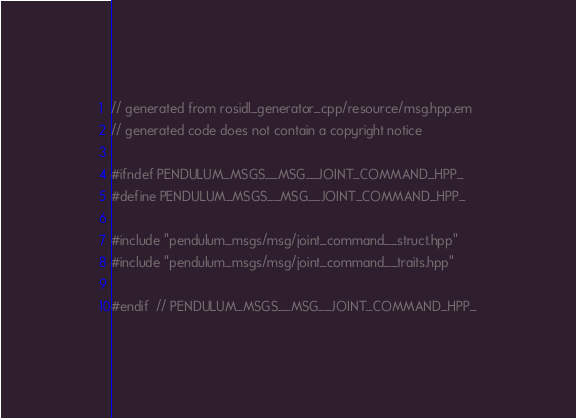Convert code to text. <code><loc_0><loc_0><loc_500><loc_500><_C++_>// generated from rosidl_generator_cpp/resource/msg.hpp.em
// generated code does not contain a copyright notice

#ifndef PENDULUM_MSGS__MSG__JOINT_COMMAND_HPP_
#define PENDULUM_MSGS__MSG__JOINT_COMMAND_HPP_

#include "pendulum_msgs/msg/joint_command__struct.hpp"
#include "pendulum_msgs/msg/joint_command__traits.hpp"

#endif  // PENDULUM_MSGS__MSG__JOINT_COMMAND_HPP_
</code> 